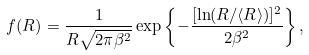Convert formula to latex. <formula><loc_0><loc_0><loc_500><loc_500>f ( R ) = \frac { 1 } { R \sqrt { 2 \pi \beta ^ { 2 } } } \exp \left \{ - \frac { [ \ln ( R / \langle R \rangle ) ] ^ { 2 } } { 2 \beta ^ { 2 } } \right \} ,</formula> 